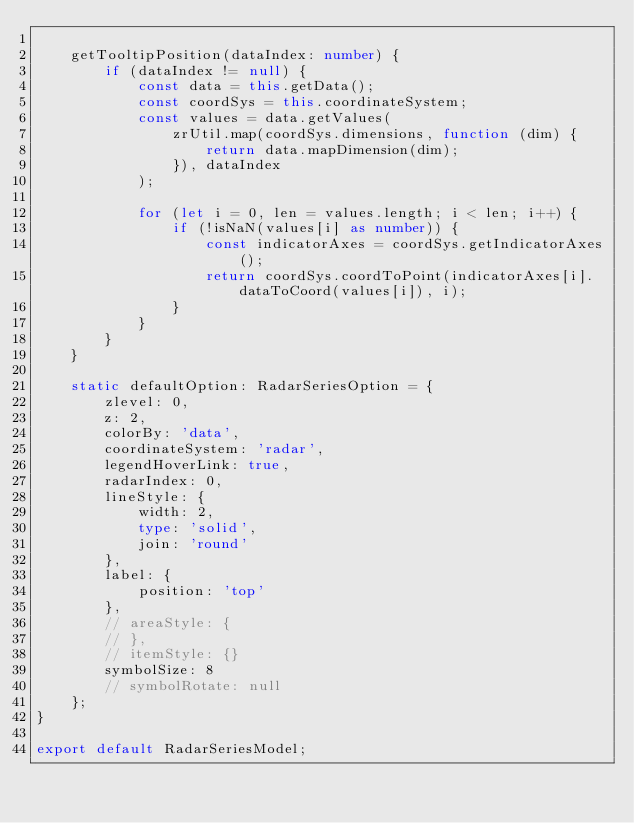<code> <loc_0><loc_0><loc_500><loc_500><_TypeScript_>
    getTooltipPosition(dataIndex: number) {
        if (dataIndex != null) {
            const data = this.getData();
            const coordSys = this.coordinateSystem;
            const values = data.getValues(
                zrUtil.map(coordSys.dimensions, function (dim) {
                    return data.mapDimension(dim);
                }), dataIndex
            );

            for (let i = 0, len = values.length; i < len; i++) {
                if (!isNaN(values[i] as number)) {
                    const indicatorAxes = coordSys.getIndicatorAxes();
                    return coordSys.coordToPoint(indicatorAxes[i].dataToCoord(values[i]), i);
                }
            }
        }
    }

    static defaultOption: RadarSeriesOption = {
        zlevel: 0,
        z: 2,
        colorBy: 'data',
        coordinateSystem: 'radar',
        legendHoverLink: true,
        radarIndex: 0,
        lineStyle: {
            width: 2,
            type: 'solid',
            join: 'round'
        },
        label: {
            position: 'top'
        },
        // areaStyle: {
        // },
        // itemStyle: {}
        symbolSize: 8
        // symbolRotate: null
    };
}

export default RadarSeriesModel;</code> 